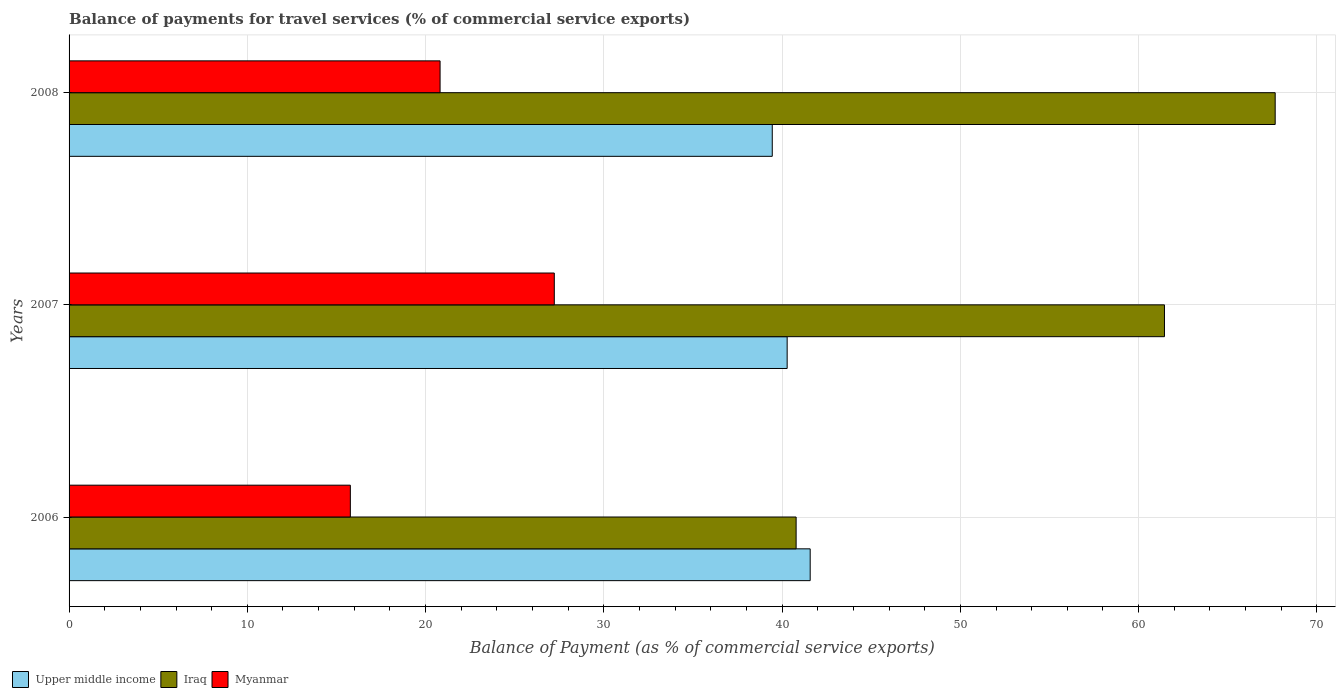How many groups of bars are there?
Offer a terse response. 3. Are the number of bars per tick equal to the number of legend labels?
Offer a very short reply. Yes. Are the number of bars on each tick of the Y-axis equal?
Offer a very short reply. Yes. How many bars are there on the 3rd tick from the top?
Ensure brevity in your answer.  3. How many bars are there on the 1st tick from the bottom?
Provide a short and direct response. 3. In how many cases, is the number of bars for a given year not equal to the number of legend labels?
Offer a terse response. 0. What is the balance of payments for travel services in Upper middle income in 2006?
Make the answer very short. 41.58. Across all years, what is the maximum balance of payments for travel services in Myanmar?
Your response must be concise. 27.22. Across all years, what is the minimum balance of payments for travel services in Iraq?
Ensure brevity in your answer.  40.79. What is the total balance of payments for travel services in Upper middle income in the graph?
Provide a succinct answer. 121.31. What is the difference between the balance of payments for travel services in Iraq in 2007 and that in 2008?
Offer a very short reply. -6.21. What is the difference between the balance of payments for travel services in Iraq in 2008 and the balance of payments for travel services in Myanmar in 2007?
Ensure brevity in your answer.  40.44. What is the average balance of payments for travel services in Myanmar per year?
Give a very brief answer. 21.27. In the year 2008, what is the difference between the balance of payments for travel services in Iraq and balance of payments for travel services in Upper middle income?
Keep it short and to the point. 28.21. In how many years, is the balance of payments for travel services in Myanmar greater than 8 %?
Make the answer very short. 3. What is the ratio of the balance of payments for travel services in Upper middle income in 2006 to that in 2008?
Provide a short and direct response. 1.05. Is the balance of payments for travel services in Iraq in 2006 less than that in 2008?
Offer a very short reply. Yes. Is the difference between the balance of payments for travel services in Iraq in 2006 and 2007 greater than the difference between the balance of payments for travel services in Upper middle income in 2006 and 2007?
Your answer should be compact. No. What is the difference between the highest and the second highest balance of payments for travel services in Iraq?
Offer a terse response. 6.21. What is the difference between the highest and the lowest balance of payments for travel services in Myanmar?
Ensure brevity in your answer.  11.44. In how many years, is the balance of payments for travel services in Iraq greater than the average balance of payments for travel services in Iraq taken over all years?
Provide a succinct answer. 2. Is the sum of the balance of payments for travel services in Iraq in 2006 and 2007 greater than the maximum balance of payments for travel services in Upper middle income across all years?
Provide a succinct answer. Yes. What does the 2nd bar from the top in 2008 represents?
Your answer should be very brief. Iraq. What does the 2nd bar from the bottom in 2006 represents?
Your response must be concise. Iraq. How many bars are there?
Make the answer very short. 9. Are all the bars in the graph horizontal?
Ensure brevity in your answer.  Yes. How many years are there in the graph?
Offer a very short reply. 3. What is the difference between two consecutive major ticks on the X-axis?
Offer a very short reply. 10. Are the values on the major ticks of X-axis written in scientific E-notation?
Provide a succinct answer. No. Where does the legend appear in the graph?
Offer a very short reply. Bottom left. How are the legend labels stacked?
Give a very brief answer. Horizontal. What is the title of the graph?
Your response must be concise. Balance of payments for travel services (% of commercial service exports). Does "Samoa" appear as one of the legend labels in the graph?
Offer a terse response. No. What is the label or title of the X-axis?
Provide a succinct answer. Balance of Payment (as % of commercial service exports). What is the Balance of Payment (as % of commercial service exports) of Upper middle income in 2006?
Your answer should be very brief. 41.58. What is the Balance of Payment (as % of commercial service exports) in Iraq in 2006?
Ensure brevity in your answer.  40.79. What is the Balance of Payment (as % of commercial service exports) of Myanmar in 2006?
Your response must be concise. 15.78. What is the Balance of Payment (as % of commercial service exports) in Upper middle income in 2007?
Your answer should be very brief. 40.28. What is the Balance of Payment (as % of commercial service exports) of Iraq in 2007?
Your answer should be very brief. 61.45. What is the Balance of Payment (as % of commercial service exports) in Myanmar in 2007?
Offer a very short reply. 27.22. What is the Balance of Payment (as % of commercial service exports) in Upper middle income in 2008?
Offer a very short reply. 39.45. What is the Balance of Payment (as % of commercial service exports) of Iraq in 2008?
Your answer should be very brief. 67.66. What is the Balance of Payment (as % of commercial service exports) in Myanmar in 2008?
Ensure brevity in your answer.  20.81. Across all years, what is the maximum Balance of Payment (as % of commercial service exports) in Upper middle income?
Provide a short and direct response. 41.58. Across all years, what is the maximum Balance of Payment (as % of commercial service exports) in Iraq?
Keep it short and to the point. 67.66. Across all years, what is the maximum Balance of Payment (as % of commercial service exports) in Myanmar?
Provide a short and direct response. 27.22. Across all years, what is the minimum Balance of Payment (as % of commercial service exports) of Upper middle income?
Keep it short and to the point. 39.45. Across all years, what is the minimum Balance of Payment (as % of commercial service exports) of Iraq?
Offer a very short reply. 40.79. Across all years, what is the minimum Balance of Payment (as % of commercial service exports) of Myanmar?
Provide a succinct answer. 15.78. What is the total Balance of Payment (as % of commercial service exports) of Upper middle income in the graph?
Provide a succinct answer. 121.31. What is the total Balance of Payment (as % of commercial service exports) of Iraq in the graph?
Keep it short and to the point. 169.9. What is the total Balance of Payment (as % of commercial service exports) of Myanmar in the graph?
Provide a succinct answer. 63.81. What is the difference between the Balance of Payment (as % of commercial service exports) in Upper middle income in 2006 and that in 2007?
Offer a very short reply. 1.29. What is the difference between the Balance of Payment (as % of commercial service exports) of Iraq in 2006 and that in 2007?
Keep it short and to the point. -20.66. What is the difference between the Balance of Payment (as % of commercial service exports) in Myanmar in 2006 and that in 2007?
Your answer should be compact. -11.44. What is the difference between the Balance of Payment (as % of commercial service exports) of Upper middle income in 2006 and that in 2008?
Keep it short and to the point. 2.13. What is the difference between the Balance of Payment (as % of commercial service exports) of Iraq in 2006 and that in 2008?
Offer a terse response. -26.88. What is the difference between the Balance of Payment (as % of commercial service exports) in Myanmar in 2006 and that in 2008?
Offer a terse response. -5.03. What is the difference between the Balance of Payment (as % of commercial service exports) in Upper middle income in 2007 and that in 2008?
Offer a very short reply. 0.84. What is the difference between the Balance of Payment (as % of commercial service exports) of Iraq in 2007 and that in 2008?
Provide a short and direct response. -6.21. What is the difference between the Balance of Payment (as % of commercial service exports) of Myanmar in 2007 and that in 2008?
Make the answer very short. 6.41. What is the difference between the Balance of Payment (as % of commercial service exports) of Upper middle income in 2006 and the Balance of Payment (as % of commercial service exports) of Iraq in 2007?
Keep it short and to the point. -19.88. What is the difference between the Balance of Payment (as % of commercial service exports) in Upper middle income in 2006 and the Balance of Payment (as % of commercial service exports) in Myanmar in 2007?
Your response must be concise. 14.36. What is the difference between the Balance of Payment (as % of commercial service exports) in Iraq in 2006 and the Balance of Payment (as % of commercial service exports) in Myanmar in 2007?
Your answer should be very brief. 13.57. What is the difference between the Balance of Payment (as % of commercial service exports) of Upper middle income in 2006 and the Balance of Payment (as % of commercial service exports) of Iraq in 2008?
Your answer should be very brief. -26.09. What is the difference between the Balance of Payment (as % of commercial service exports) in Upper middle income in 2006 and the Balance of Payment (as % of commercial service exports) in Myanmar in 2008?
Ensure brevity in your answer.  20.76. What is the difference between the Balance of Payment (as % of commercial service exports) of Iraq in 2006 and the Balance of Payment (as % of commercial service exports) of Myanmar in 2008?
Your response must be concise. 19.97. What is the difference between the Balance of Payment (as % of commercial service exports) of Upper middle income in 2007 and the Balance of Payment (as % of commercial service exports) of Iraq in 2008?
Your answer should be very brief. -27.38. What is the difference between the Balance of Payment (as % of commercial service exports) in Upper middle income in 2007 and the Balance of Payment (as % of commercial service exports) in Myanmar in 2008?
Your response must be concise. 19.47. What is the difference between the Balance of Payment (as % of commercial service exports) of Iraq in 2007 and the Balance of Payment (as % of commercial service exports) of Myanmar in 2008?
Your answer should be very brief. 40.64. What is the average Balance of Payment (as % of commercial service exports) of Upper middle income per year?
Make the answer very short. 40.44. What is the average Balance of Payment (as % of commercial service exports) of Iraq per year?
Offer a terse response. 56.63. What is the average Balance of Payment (as % of commercial service exports) of Myanmar per year?
Your answer should be compact. 21.27. In the year 2006, what is the difference between the Balance of Payment (as % of commercial service exports) in Upper middle income and Balance of Payment (as % of commercial service exports) in Iraq?
Provide a short and direct response. 0.79. In the year 2006, what is the difference between the Balance of Payment (as % of commercial service exports) in Upper middle income and Balance of Payment (as % of commercial service exports) in Myanmar?
Provide a short and direct response. 25.8. In the year 2006, what is the difference between the Balance of Payment (as % of commercial service exports) in Iraq and Balance of Payment (as % of commercial service exports) in Myanmar?
Give a very brief answer. 25.01. In the year 2007, what is the difference between the Balance of Payment (as % of commercial service exports) of Upper middle income and Balance of Payment (as % of commercial service exports) of Iraq?
Your answer should be compact. -21.17. In the year 2007, what is the difference between the Balance of Payment (as % of commercial service exports) of Upper middle income and Balance of Payment (as % of commercial service exports) of Myanmar?
Your answer should be compact. 13.06. In the year 2007, what is the difference between the Balance of Payment (as % of commercial service exports) of Iraq and Balance of Payment (as % of commercial service exports) of Myanmar?
Offer a very short reply. 34.23. In the year 2008, what is the difference between the Balance of Payment (as % of commercial service exports) of Upper middle income and Balance of Payment (as % of commercial service exports) of Iraq?
Make the answer very short. -28.21. In the year 2008, what is the difference between the Balance of Payment (as % of commercial service exports) of Upper middle income and Balance of Payment (as % of commercial service exports) of Myanmar?
Ensure brevity in your answer.  18.64. In the year 2008, what is the difference between the Balance of Payment (as % of commercial service exports) in Iraq and Balance of Payment (as % of commercial service exports) in Myanmar?
Your answer should be very brief. 46.85. What is the ratio of the Balance of Payment (as % of commercial service exports) in Upper middle income in 2006 to that in 2007?
Your answer should be compact. 1.03. What is the ratio of the Balance of Payment (as % of commercial service exports) in Iraq in 2006 to that in 2007?
Offer a very short reply. 0.66. What is the ratio of the Balance of Payment (as % of commercial service exports) of Myanmar in 2006 to that in 2007?
Provide a succinct answer. 0.58. What is the ratio of the Balance of Payment (as % of commercial service exports) of Upper middle income in 2006 to that in 2008?
Ensure brevity in your answer.  1.05. What is the ratio of the Balance of Payment (as % of commercial service exports) of Iraq in 2006 to that in 2008?
Offer a very short reply. 0.6. What is the ratio of the Balance of Payment (as % of commercial service exports) in Myanmar in 2006 to that in 2008?
Make the answer very short. 0.76. What is the ratio of the Balance of Payment (as % of commercial service exports) of Upper middle income in 2007 to that in 2008?
Provide a succinct answer. 1.02. What is the ratio of the Balance of Payment (as % of commercial service exports) in Iraq in 2007 to that in 2008?
Ensure brevity in your answer.  0.91. What is the ratio of the Balance of Payment (as % of commercial service exports) in Myanmar in 2007 to that in 2008?
Your answer should be very brief. 1.31. What is the difference between the highest and the second highest Balance of Payment (as % of commercial service exports) of Upper middle income?
Provide a succinct answer. 1.29. What is the difference between the highest and the second highest Balance of Payment (as % of commercial service exports) in Iraq?
Make the answer very short. 6.21. What is the difference between the highest and the second highest Balance of Payment (as % of commercial service exports) of Myanmar?
Make the answer very short. 6.41. What is the difference between the highest and the lowest Balance of Payment (as % of commercial service exports) in Upper middle income?
Keep it short and to the point. 2.13. What is the difference between the highest and the lowest Balance of Payment (as % of commercial service exports) of Iraq?
Ensure brevity in your answer.  26.88. What is the difference between the highest and the lowest Balance of Payment (as % of commercial service exports) of Myanmar?
Make the answer very short. 11.44. 